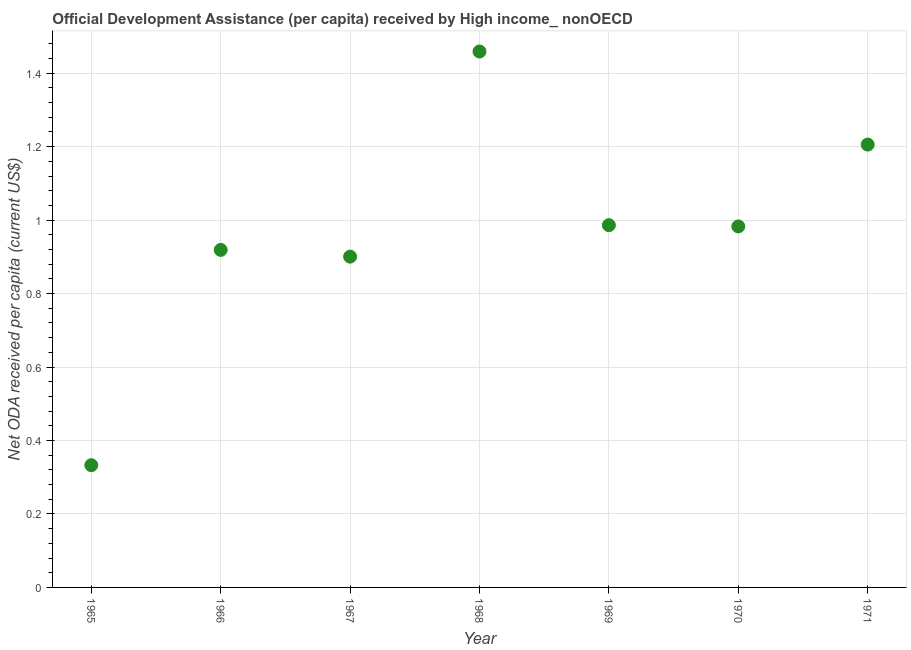What is the net oda received per capita in 1968?
Provide a succinct answer. 1.46. Across all years, what is the maximum net oda received per capita?
Give a very brief answer. 1.46. Across all years, what is the minimum net oda received per capita?
Offer a terse response. 0.33. In which year was the net oda received per capita maximum?
Make the answer very short. 1968. In which year was the net oda received per capita minimum?
Give a very brief answer. 1965. What is the sum of the net oda received per capita?
Make the answer very short. 6.79. What is the difference between the net oda received per capita in 1967 and 1970?
Keep it short and to the point. -0.08. What is the average net oda received per capita per year?
Ensure brevity in your answer.  0.97. What is the median net oda received per capita?
Your answer should be very brief. 0.98. Do a majority of the years between 1970 and 1965 (inclusive) have net oda received per capita greater than 0.32 US$?
Provide a succinct answer. Yes. What is the ratio of the net oda received per capita in 1967 to that in 1969?
Keep it short and to the point. 0.91. Is the net oda received per capita in 1966 less than that in 1970?
Your answer should be very brief. Yes. What is the difference between the highest and the second highest net oda received per capita?
Offer a terse response. 0.25. Is the sum of the net oda received per capita in 1965 and 1968 greater than the maximum net oda received per capita across all years?
Give a very brief answer. Yes. What is the difference between the highest and the lowest net oda received per capita?
Provide a short and direct response. 1.13. Does the net oda received per capita monotonically increase over the years?
Your answer should be compact. No. How many dotlines are there?
Provide a succinct answer. 1. How many years are there in the graph?
Give a very brief answer. 7. What is the difference between two consecutive major ticks on the Y-axis?
Your response must be concise. 0.2. Are the values on the major ticks of Y-axis written in scientific E-notation?
Your answer should be very brief. No. Does the graph contain grids?
Keep it short and to the point. Yes. What is the title of the graph?
Your answer should be very brief. Official Development Assistance (per capita) received by High income_ nonOECD. What is the label or title of the X-axis?
Give a very brief answer. Year. What is the label or title of the Y-axis?
Ensure brevity in your answer.  Net ODA received per capita (current US$). What is the Net ODA received per capita (current US$) in 1965?
Provide a short and direct response. 0.33. What is the Net ODA received per capita (current US$) in 1966?
Make the answer very short. 0.92. What is the Net ODA received per capita (current US$) in 1967?
Give a very brief answer. 0.9. What is the Net ODA received per capita (current US$) in 1968?
Give a very brief answer. 1.46. What is the Net ODA received per capita (current US$) in 1969?
Your answer should be compact. 0.99. What is the Net ODA received per capita (current US$) in 1970?
Your response must be concise. 0.98. What is the Net ODA received per capita (current US$) in 1971?
Make the answer very short. 1.21. What is the difference between the Net ODA received per capita (current US$) in 1965 and 1966?
Provide a short and direct response. -0.59. What is the difference between the Net ODA received per capita (current US$) in 1965 and 1967?
Your answer should be compact. -0.57. What is the difference between the Net ODA received per capita (current US$) in 1965 and 1968?
Your answer should be compact. -1.13. What is the difference between the Net ODA received per capita (current US$) in 1965 and 1969?
Make the answer very short. -0.65. What is the difference between the Net ODA received per capita (current US$) in 1965 and 1970?
Your answer should be very brief. -0.65. What is the difference between the Net ODA received per capita (current US$) in 1965 and 1971?
Provide a short and direct response. -0.87. What is the difference between the Net ODA received per capita (current US$) in 1966 and 1967?
Give a very brief answer. 0.02. What is the difference between the Net ODA received per capita (current US$) in 1966 and 1968?
Ensure brevity in your answer.  -0.54. What is the difference between the Net ODA received per capita (current US$) in 1966 and 1969?
Your answer should be very brief. -0.07. What is the difference between the Net ODA received per capita (current US$) in 1966 and 1970?
Keep it short and to the point. -0.06. What is the difference between the Net ODA received per capita (current US$) in 1966 and 1971?
Your answer should be very brief. -0.29. What is the difference between the Net ODA received per capita (current US$) in 1967 and 1968?
Offer a terse response. -0.56. What is the difference between the Net ODA received per capita (current US$) in 1967 and 1969?
Your answer should be compact. -0.09. What is the difference between the Net ODA received per capita (current US$) in 1967 and 1970?
Offer a terse response. -0.08. What is the difference between the Net ODA received per capita (current US$) in 1967 and 1971?
Give a very brief answer. -0.31. What is the difference between the Net ODA received per capita (current US$) in 1968 and 1969?
Your answer should be compact. 0.47. What is the difference between the Net ODA received per capita (current US$) in 1968 and 1970?
Offer a very short reply. 0.48. What is the difference between the Net ODA received per capita (current US$) in 1968 and 1971?
Your answer should be compact. 0.25. What is the difference between the Net ODA received per capita (current US$) in 1969 and 1970?
Ensure brevity in your answer.  0. What is the difference between the Net ODA received per capita (current US$) in 1969 and 1971?
Offer a very short reply. -0.22. What is the difference between the Net ODA received per capita (current US$) in 1970 and 1971?
Your answer should be compact. -0.22. What is the ratio of the Net ODA received per capita (current US$) in 1965 to that in 1966?
Give a very brief answer. 0.36. What is the ratio of the Net ODA received per capita (current US$) in 1965 to that in 1967?
Your answer should be compact. 0.37. What is the ratio of the Net ODA received per capita (current US$) in 1965 to that in 1968?
Provide a succinct answer. 0.23. What is the ratio of the Net ODA received per capita (current US$) in 1965 to that in 1969?
Make the answer very short. 0.34. What is the ratio of the Net ODA received per capita (current US$) in 1965 to that in 1970?
Make the answer very short. 0.34. What is the ratio of the Net ODA received per capita (current US$) in 1965 to that in 1971?
Keep it short and to the point. 0.28. What is the ratio of the Net ODA received per capita (current US$) in 1966 to that in 1968?
Provide a succinct answer. 0.63. What is the ratio of the Net ODA received per capita (current US$) in 1966 to that in 1969?
Keep it short and to the point. 0.93. What is the ratio of the Net ODA received per capita (current US$) in 1966 to that in 1970?
Keep it short and to the point. 0.94. What is the ratio of the Net ODA received per capita (current US$) in 1966 to that in 1971?
Your response must be concise. 0.76. What is the ratio of the Net ODA received per capita (current US$) in 1967 to that in 1968?
Provide a short and direct response. 0.62. What is the ratio of the Net ODA received per capita (current US$) in 1967 to that in 1969?
Your response must be concise. 0.91. What is the ratio of the Net ODA received per capita (current US$) in 1967 to that in 1970?
Provide a succinct answer. 0.92. What is the ratio of the Net ODA received per capita (current US$) in 1967 to that in 1971?
Provide a succinct answer. 0.75. What is the ratio of the Net ODA received per capita (current US$) in 1968 to that in 1969?
Provide a short and direct response. 1.48. What is the ratio of the Net ODA received per capita (current US$) in 1968 to that in 1970?
Your response must be concise. 1.49. What is the ratio of the Net ODA received per capita (current US$) in 1968 to that in 1971?
Your response must be concise. 1.21. What is the ratio of the Net ODA received per capita (current US$) in 1969 to that in 1970?
Ensure brevity in your answer.  1. What is the ratio of the Net ODA received per capita (current US$) in 1969 to that in 1971?
Give a very brief answer. 0.82. What is the ratio of the Net ODA received per capita (current US$) in 1970 to that in 1971?
Make the answer very short. 0.81. 